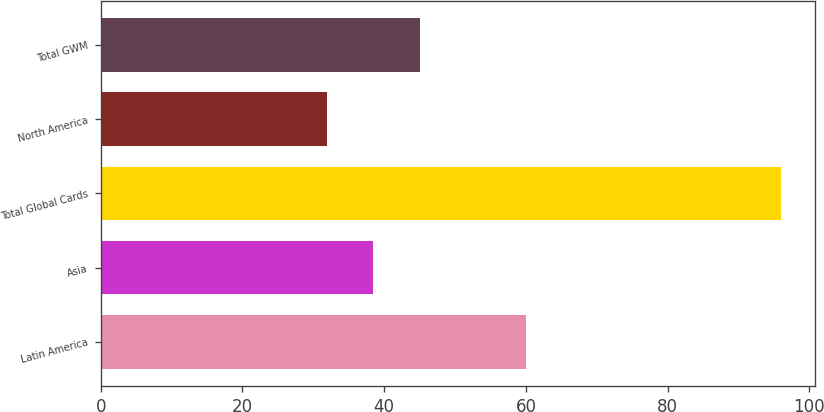<chart> <loc_0><loc_0><loc_500><loc_500><bar_chart><fcel>Latin America<fcel>Asia<fcel>Total Global Cards<fcel>North America<fcel>Total GWM<nl><fcel>60<fcel>38.4<fcel>96<fcel>32<fcel>45<nl></chart> 